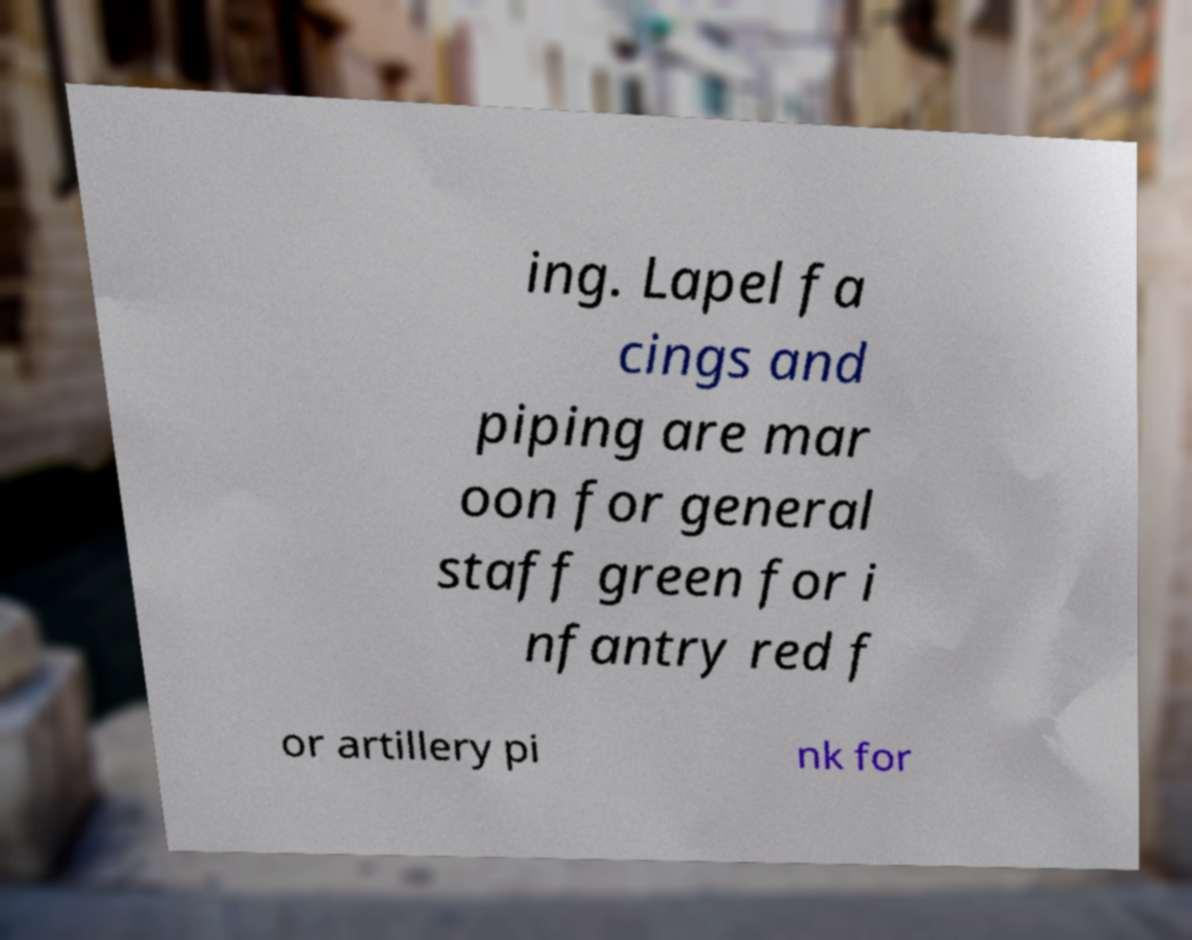Please read and relay the text visible in this image. What does it say? ing. Lapel fa cings and piping are mar oon for general staff green for i nfantry red f or artillery pi nk for 